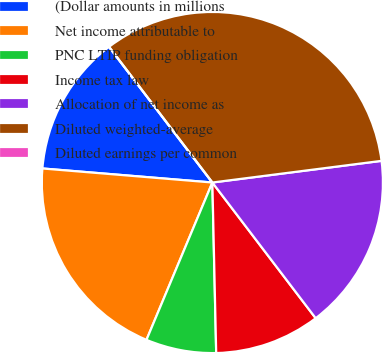Convert chart to OTSL. <chart><loc_0><loc_0><loc_500><loc_500><pie_chart><fcel>(Dollar amounts in millions<fcel>Net income attributable to<fcel>PNC LTIP funding obligation<fcel>Income tax law<fcel>Allocation of net income as<fcel>Diluted weighted-average<fcel>Diluted earnings per common<nl><fcel>13.33%<fcel>20.0%<fcel>6.67%<fcel>10.0%<fcel>16.67%<fcel>33.33%<fcel>0.0%<nl></chart> 